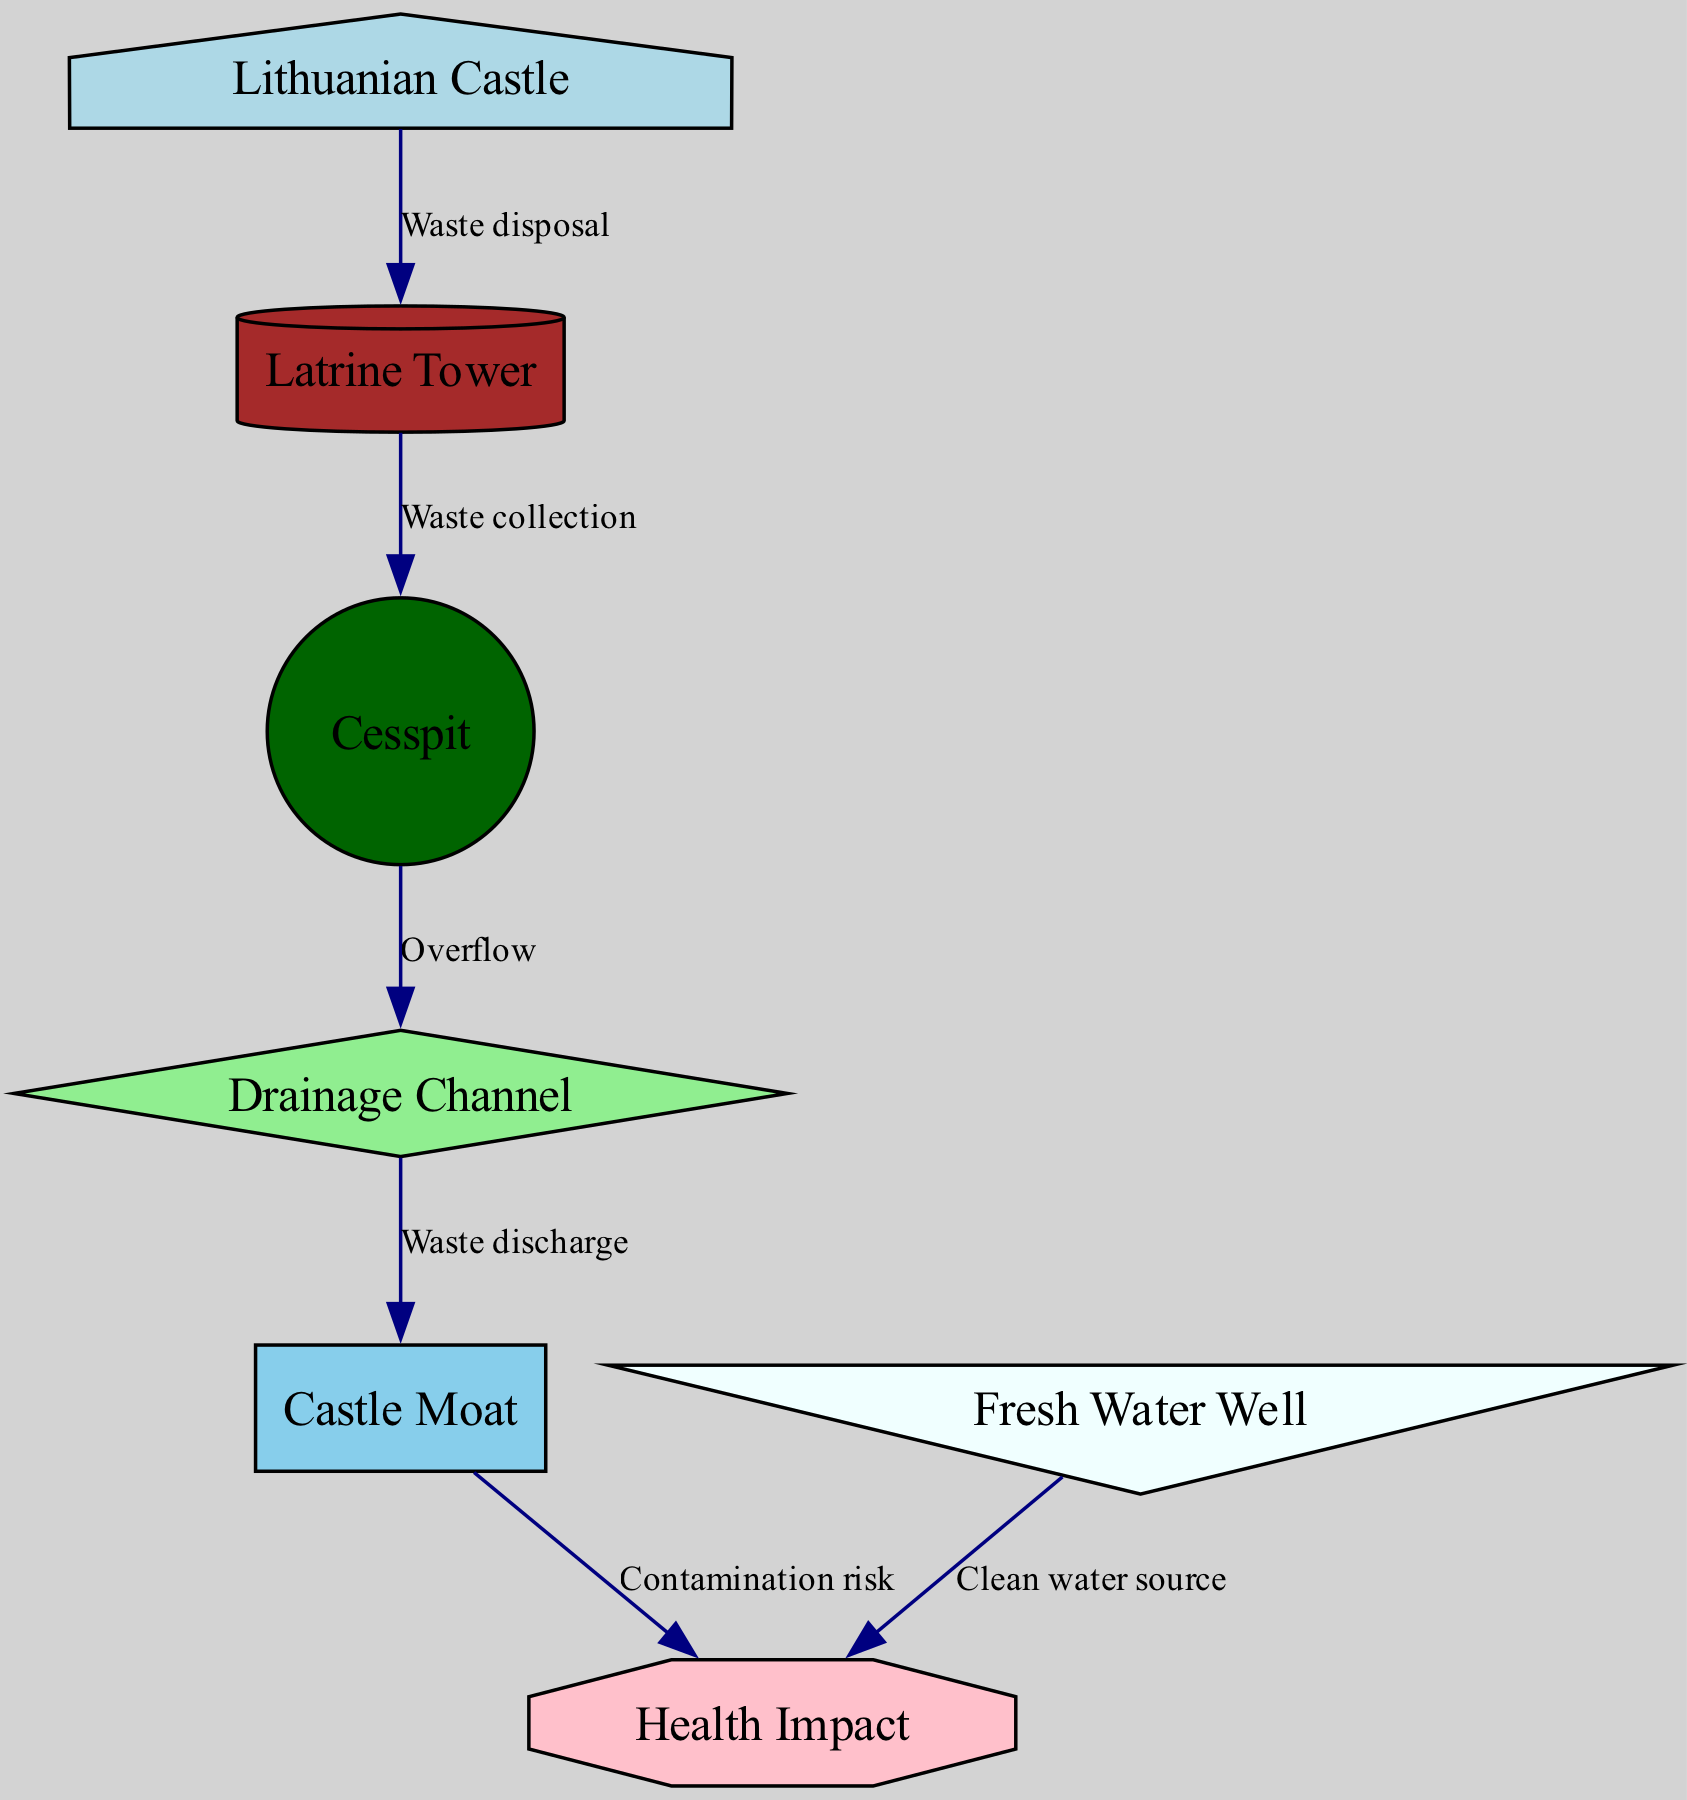What is the main function of the latrine tower? The diagram indicates that the latrine tower is used for waste disposal, as shown by the edge labeled "Waste disposal" connecting the castle to the latrine.
Answer: Waste disposal How many connections does the cesspit have? The cesspit is linked by two edges: one directing to the drainage channel (labeled "Overflow") and one from the latrine tower (labeled "Waste collection"). This means it has two direct connections.
Answer: 2 What is the role of the fresh water well? The fresh water well contributes positively to health by being a clean water source, as evidenced by the edge labeled "Clean water source" pointing towards the health node.
Answer: Clean water source What potential risk does the castle moat pose? The moat is indicated to pose a contamination risk, connecting to the health impact node through the edge labeled "Contamination risk".
Answer: Contamination risk What connects the cesspit and the moat? The drainage channel serves as the connecting node between the cesspit and the moat, facilitating waste discharge according to the labeled edge indicating "Waste discharge".
Answer: Drainage channel What does the castle's sanitation system primarily involve? The sanitation system of the castle primarily involves waste travel from the castle through the latrine tower to the cesspit, and subsequently through the drainage to the moat. This flow highlights the systematic management of waste.
Answer: Waste management How does the sanitation system impact health? Health impact is influenced by the waste management process: the moat can cause contamination and the fresh water well can promote good health by providing clean water—both paths converge at the health node.
Answer: Health impact Which node represents the source of fresh water? The fresh water well is the node specifically representing the source of clean water and is directly linked to the health aspects of the castle.
Answer: Fresh Water Well 